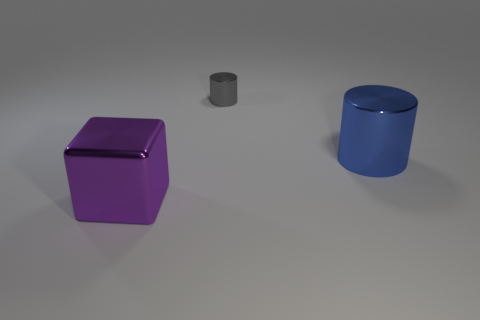Is there anything else that is the same shape as the purple object?
Make the answer very short. No. There is a metal cylinder that is in front of the tiny gray metallic thing; what is its color?
Your answer should be compact. Blue. Are there an equal number of gray metal things right of the large blue thing and big cyan shiny cylinders?
Your answer should be compact. Yes. How many other things are the same shape as the blue metal thing?
Keep it short and to the point. 1. How many blocks are in front of the big metal cube?
Your answer should be very brief. 0. What size is the object that is right of the big purple cube and on the left side of the big blue thing?
Provide a short and direct response. Small. Are any large green rubber cylinders visible?
Your response must be concise. No. What number of other objects are the same size as the purple metallic cube?
Make the answer very short. 1. What size is the blue shiny thing that is the same shape as the gray object?
Your response must be concise. Large. How many metal things are tiny gray things or big purple blocks?
Offer a very short reply. 2. 